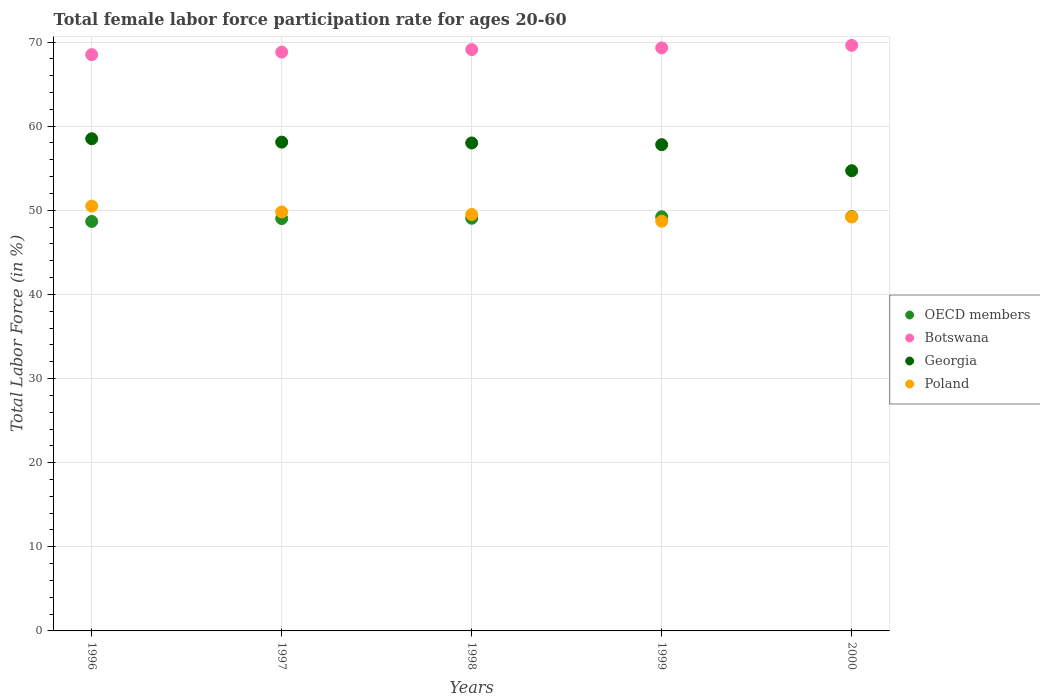How many different coloured dotlines are there?
Offer a very short reply. 4. Is the number of dotlines equal to the number of legend labels?
Your answer should be very brief. Yes. What is the female labor force participation rate in Georgia in 1999?
Ensure brevity in your answer.  57.8. Across all years, what is the maximum female labor force participation rate in Botswana?
Offer a very short reply. 69.6. Across all years, what is the minimum female labor force participation rate in Botswana?
Offer a very short reply. 68.5. In which year was the female labor force participation rate in Botswana maximum?
Provide a succinct answer. 2000. What is the total female labor force participation rate in Georgia in the graph?
Provide a succinct answer. 287.1. What is the difference between the female labor force participation rate in OECD members in 1997 and that in 1998?
Offer a terse response. -0.04. What is the difference between the female labor force participation rate in OECD members in 1999 and the female labor force participation rate in Georgia in 2000?
Your response must be concise. -5.47. What is the average female labor force participation rate in Botswana per year?
Give a very brief answer. 69.06. In the year 2000, what is the difference between the female labor force participation rate in Poland and female labor force participation rate in Botswana?
Your response must be concise. -20.4. In how many years, is the female labor force participation rate in Georgia greater than 64 %?
Offer a terse response. 0. What is the ratio of the female labor force participation rate in Botswana in 1996 to that in 1998?
Keep it short and to the point. 0.99. Is the difference between the female labor force participation rate in Poland in 1997 and 2000 greater than the difference between the female labor force participation rate in Botswana in 1997 and 2000?
Your answer should be compact. Yes. What is the difference between the highest and the second highest female labor force participation rate in Georgia?
Give a very brief answer. 0.4. What is the difference between the highest and the lowest female labor force participation rate in Botswana?
Keep it short and to the point. 1.1. In how many years, is the female labor force participation rate in Poland greater than the average female labor force participation rate in Poland taken over all years?
Your answer should be compact. 2. Is the sum of the female labor force participation rate in Botswana in 1997 and 1998 greater than the maximum female labor force participation rate in Poland across all years?
Ensure brevity in your answer.  Yes. Is it the case that in every year, the sum of the female labor force participation rate in Poland and female labor force participation rate in Georgia  is greater than the sum of female labor force participation rate in Botswana and female labor force participation rate in OECD members?
Keep it short and to the point. No. Is it the case that in every year, the sum of the female labor force participation rate in Poland and female labor force participation rate in Georgia  is greater than the female labor force participation rate in Botswana?
Ensure brevity in your answer.  Yes. How many years are there in the graph?
Your answer should be very brief. 5. Does the graph contain grids?
Your response must be concise. Yes. Where does the legend appear in the graph?
Offer a very short reply. Center right. What is the title of the graph?
Ensure brevity in your answer.  Total female labor force participation rate for ages 20-60. Does "Uganda" appear as one of the legend labels in the graph?
Provide a succinct answer. No. What is the label or title of the Y-axis?
Your answer should be compact. Total Labor Force (in %). What is the Total Labor Force (in %) of OECD members in 1996?
Provide a short and direct response. 48.67. What is the Total Labor Force (in %) of Botswana in 1996?
Your response must be concise. 68.5. What is the Total Labor Force (in %) in Georgia in 1996?
Give a very brief answer. 58.5. What is the Total Labor Force (in %) in Poland in 1996?
Give a very brief answer. 50.5. What is the Total Labor Force (in %) of OECD members in 1997?
Make the answer very short. 49.01. What is the Total Labor Force (in %) of Botswana in 1997?
Offer a very short reply. 68.8. What is the Total Labor Force (in %) in Georgia in 1997?
Your answer should be very brief. 58.1. What is the Total Labor Force (in %) of Poland in 1997?
Offer a terse response. 49.8. What is the Total Labor Force (in %) of OECD members in 1998?
Offer a terse response. 49.05. What is the Total Labor Force (in %) of Botswana in 1998?
Make the answer very short. 69.1. What is the Total Labor Force (in %) of Poland in 1998?
Offer a very short reply. 49.5. What is the Total Labor Force (in %) of OECD members in 1999?
Make the answer very short. 49.23. What is the Total Labor Force (in %) of Botswana in 1999?
Your answer should be compact. 69.3. What is the Total Labor Force (in %) in Georgia in 1999?
Provide a succinct answer. 57.8. What is the Total Labor Force (in %) in Poland in 1999?
Ensure brevity in your answer.  48.7. What is the Total Labor Force (in %) of OECD members in 2000?
Offer a very short reply. 49.25. What is the Total Labor Force (in %) in Botswana in 2000?
Provide a succinct answer. 69.6. What is the Total Labor Force (in %) of Georgia in 2000?
Provide a short and direct response. 54.7. What is the Total Labor Force (in %) in Poland in 2000?
Your response must be concise. 49.2. Across all years, what is the maximum Total Labor Force (in %) of OECD members?
Provide a succinct answer. 49.25. Across all years, what is the maximum Total Labor Force (in %) in Botswana?
Offer a terse response. 69.6. Across all years, what is the maximum Total Labor Force (in %) of Georgia?
Make the answer very short. 58.5. Across all years, what is the maximum Total Labor Force (in %) of Poland?
Ensure brevity in your answer.  50.5. Across all years, what is the minimum Total Labor Force (in %) in OECD members?
Give a very brief answer. 48.67. Across all years, what is the minimum Total Labor Force (in %) of Botswana?
Give a very brief answer. 68.5. Across all years, what is the minimum Total Labor Force (in %) of Georgia?
Make the answer very short. 54.7. Across all years, what is the minimum Total Labor Force (in %) of Poland?
Keep it short and to the point. 48.7. What is the total Total Labor Force (in %) in OECD members in the graph?
Provide a short and direct response. 245.21. What is the total Total Labor Force (in %) of Botswana in the graph?
Your answer should be very brief. 345.3. What is the total Total Labor Force (in %) in Georgia in the graph?
Your answer should be very brief. 287.1. What is the total Total Labor Force (in %) in Poland in the graph?
Keep it short and to the point. 247.7. What is the difference between the Total Labor Force (in %) of OECD members in 1996 and that in 1997?
Keep it short and to the point. -0.34. What is the difference between the Total Labor Force (in %) in Botswana in 1996 and that in 1997?
Ensure brevity in your answer.  -0.3. What is the difference between the Total Labor Force (in %) of OECD members in 1996 and that in 1998?
Keep it short and to the point. -0.38. What is the difference between the Total Labor Force (in %) of OECD members in 1996 and that in 1999?
Provide a short and direct response. -0.55. What is the difference between the Total Labor Force (in %) in Botswana in 1996 and that in 1999?
Provide a succinct answer. -0.8. What is the difference between the Total Labor Force (in %) in Georgia in 1996 and that in 1999?
Offer a terse response. 0.7. What is the difference between the Total Labor Force (in %) in Poland in 1996 and that in 1999?
Keep it short and to the point. 1.8. What is the difference between the Total Labor Force (in %) of OECD members in 1996 and that in 2000?
Your response must be concise. -0.58. What is the difference between the Total Labor Force (in %) in OECD members in 1997 and that in 1998?
Your answer should be compact. -0.04. What is the difference between the Total Labor Force (in %) of Georgia in 1997 and that in 1998?
Provide a succinct answer. 0.1. What is the difference between the Total Labor Force (in %) in OECD members in 1997 and that in 1999?
Ensure brevity in your answer.  -0.21. What is the difference between the Total Labor Force (in %) of Georgia in 1997 and that in 1999?
Give a very brief answer. 0.3. What is the difference between the Total Labor Force (in %) of Poland in 1997 and that in 1999?
Give a very brief answer. 1.1. What is the difference between the Total Labor Force (in %) in OECD members in 1997 and that in 2000?
Your answer should be very brief. -0.24. What is the difference between the Total Labor Force (in %) in Poland in 1997 and that in 2000?
Make the answer very short. 0.6. What is the difference between the Total Labor Force (in %) of OECD members in 1998 and that in 1999?
Offer a very short reply. -0.17. What is the difference between the Total Labor Force (in %) in Georgia in 1998 and that in 1999?
Provide a succinct answer. 0.2. What is the difference between the Total Labor Force (in %) of OECD members in 1998 and that in 2000?
Provide a short and direct response. -0.2. What is the difference between the Total Labor Force (in %) of Botswana in 1998 and that in 2000?
Offer a terse response. -0.5. What is the difference between the Total Labor Force (in %) in Georgia in 1998 and that in 2000?
Make the answer very short. 3.3. What is the difference between the Total Labor Force (in %) of OECD members in 1999 and that in 2000?
Keep it short and to the point. -0.02. What is the difference between the Total Labor Force (in %) of Georgia in 1999 and that in 2000?
Offer a very short reply. 3.1. What is the difference between the Total Labor Force (in %) in Poland in 1999 and that in 2000?
Your answer should be compact. -0.5. What is the difference between the Total Labor Force (in %) of OECD members in 1996 and the Total Labor Force (in %) of Botswana in 1997?
Provide a succinct answer. -20.13. What is the difference between the Total Labor Force (in %) in OECD members in 1996 and the Total Labor Force (in %) in Georgia in 1997?
Offer a very short reply. -9.43. What is the difference between the Total Labor Force (in %) of OECD members in 1996 and the Total Labor Force (in %) of Poland in 1997?
Provide a short and direct response. -1.13. What is the difference between the Total Labor Force (in %) in Botswana in 1996 and the Total Labor Force (in %) in Georgia in 1997?
Offer a terse response. 10.4. What is the difference between the Total Labor Force (in %) of Botswana in 1996 and the Total Labor Force (in %) of Poland in 1997?
Provide a succinct answer. 18.7. What is the difference between the Total Labor Force (in %) in OECD members in 1996 and the Total Labor Force (in %) in Botswana in 1998?
Offer a very short reply. -20.43. What is the difference between the Total Labor Force (in %) of OECD members in 1996 and the Total Labor Force (in %) of Georgia in 1998?
Ensure brevity in your answer.  -9.33. What is the difference between the Total Labor Force (in %) in OECD members in 1996 and the Total Labor Force (in %) in Poland in 1998?
Your answer should be compact. -0.83. What is the difference between the Total Labor Force (in %) in Botswana in 1996 and the Total Labor Force (in %) in Poland in 1998?
Offer a terse response. 19. What is the difference between the Total Labor Force (in %) of Georgia in 1996 and the Total Labor Force (in %) of Poland in 1998?
Offer a very short reply. 9. What is the difference between the Total Labor Force (in %) of OECD members in 1996 and the Total Labor Force (in %) of Botswana in 1999?
Ensure brevity in your answer.  -20.63. What is the difference between the Total Labor Force (in %) of OECD members in 1996 and the Total Labor Force (in %) of Georgia in 1999?
Make the answer very short. -9.13. What is the difference between the Total Labor Force (in %) in OECD members in 1996 and the Total Labor Force (in %) in Poland in 1999?
Your answer should be compact. -0.03. What is the difference between the Total Labor Force (in %) of Botswana in 1996 and the Total Labor Force (in %) of Georgia in 1999?
Your answer should be very brief. 10.7. What is the difference between the Total Labor Force (in %) in Botswana in 1996 and the Total Labor Force (in %) in Poland in 1999?
Ensure brevity in your answer.  19.8. What is the difference between the Total Labor Force (in %) in OECD members in 1996 and the Total Labor Force (in %) in Botswana in 2000?
Offer a terse response. -20.93. What is the difference between the Total Labor Force (in %) of OECD members in 1996 and the Total Labor Force (in %) of Georgia in 2000?
Your response must be concise. -6.03. What is the difference between the Total Labor Force (in %) of OECD members in 1996 and the Total Labor Force (in %) of Poland in 2000?
Make the answer very short. -0.53. What is the difference between the Total Labor Force (in %) of Botswana in 1996 and the Total Labor Force (in %) of Georgia in 2000?
Ensure brevity in your answer.  13.8. What is the difference between the Total Labor Force (in %) in Botswana in 1996 and the Total Labor Force (in %) in Poland in 2000?
Provide a succinct answer. 19.3. What is the difference between the Total Labor Force (in %) in OECD members in 1997 and the Total Labor Force (in %) in Botswana in 1998?
Give a very brief answer. -20.09. What is the difference between the Total Labor Force (in %) of OECD members in 1997 and the Total Labor Force (in %) of Georgia in 1998?
Give a very brief answer. -8.99. What is the difference between the Total Labor Force (in %) of OECD members in 1997 and the Total Labor Force (in %) of Poland in 1998?
Ensure brevity in your answer.  -0.49. What is the difference between the Total Labor Force (in %) of Botswana in 1997 and the Total Labor Force (in %) of Poland in 1998?
Ensure brevity in your answer.  19.3. What is the difference between the Total Labor Force (in %) in Georgia in 1997 and the Total Labor Force (in %) in Poland in 1998?
Offer a terse response. 8.6. What is the difference between the Total Labor Force (in %) of OECD members in 1997 and the Total Labor Force (in %) of Botswana in 1999?
Your answer should be compact. -20.29. What is the difference between the Total Labor Force (in %) in OECD members in 1997 and the Total Labor Force (in %) in Georgia in 1999?
Keep it short and to the point. -8.79. What is the difference between the Total Labor Force (in %) of OECD members in 1997 and the Total Labor Force (in %) of Poland in 1999?
Offer a terse response. 0.31. What is the difference between the Total Labor Force (in %) in Botswana in 1997 and the Total Labor Force (in %) in Poland in 1999?
Offer a very short reply. 20.1. What is the difference between the Total Labor Force (in %) of OECD members in 1997 and the Total Labor Force (in %) of Botswana in 2000?
Ensure brevity in your answer.  -20.59. What is the difference between the Total Labor Force (in %) in OECD members in 1997 and the Total Labor Force (in %) in Georgia in 2000?
Offer a terse response. -5.69. What is the difference between the Total Labor Force (in %) of OECD members in 1997 and the Total Labor Force (in %) of Poland in 2000?
Your response must be concise. -0.19. What is the difference between the Total Labor Force (in %) of Botswana in 1997 and the Total Labor Force (in %) of Georgia in 2000?
Offer a very short reply. 14.1. What is the difference between the Total Labor Force (in %) in Botswana in 1997 and the Total Labor Force (in %) in Poland in 2000?
Offer a terse response. 19.6. What is the difference between the Total Labor Force (in %) in Georgia in 1997 and the Total Labor Force (in %) in Poland in 2000?
Provide a short and direct response. 8.9. What is the difference between the Total Labor Force (in %) in OECD members in 1998 and the Total Labor Force (in %) in Botswana in 1999?
Provide a succinct answer. -20.25. What is the difference between the Total Labor Force (in %) of OECD members in 1998 and the Total Labor Force (in %) of Georgia in 1999?
Your answer should be compact. -8.75. What is the difference between the Total Labor Force (in %) of OECD members in 1998 and the Total Labor Force (in %) of Poland in 1999?
Offer a terse response. 0.35. What is the difference between the Total Labor Force (in %) in Botswana in 1998 and the Total Labor Force (in %) in Georgia in 1999?
Your answer should be compact. 11.3. What is the difference between the Total Labor Force (in %) in Botswana in 1998 and the Total Labor Force (in %) in Poland in 1999?
Provide a succinct answer. 20.4. What is the difference between the Total Labor Force (in %) in OECD members in 1998 and the Total Labor Force (in %) in Botswana in 2000?
Your answer should be very brief. -20.55. What is the difference between the Total Labor Force (in %) in OECD members in 1998 and the Total Labor Force (in %) in Georgia in 2000?
Your answer should be compact. -5.65. What is the difference between the Total Labor Force (in %) of OECD members in 1998 and the Total Labor Force (in %) of Poland in 2000?
Make the answer very short. -0.15. What is the difference between the Total Labor Force (in %) of Botswana in 1998 and the Total Labor Force (in %) of Georgia in 2000?
Offer a terse response. 14.4. What is the difference between the Total Labor Force (in %) of Georgia in 1998 and the Total Labor Force (in %) of Poland in 2000?
Offer a terse response. 8.8. What is the difference between the Total Labor Force (in %) of OECD members in 1999 and the Total Labor Force (in %) of Botswana in 2000?
Your answer should be compact. -20.37. What is the difference between the Total Labor Force (in %) in OECD members in 1999 and the Total Labor Force (in %) in Georgia in 2000?
Provide a short and direct response. -5.47. What is the difference between the Total Labor Force (in %) of OECD members in 1999 and the Total Labor Force (in %) of Poland in 2000?
Provide a succinct answer. 0.03. What is the difference between the Total Labor Force (in %) in Botswana in 1999 and the Total Labor Force (in %) in Georgia in 2000?
Make the answer very short. 14.6. What is the difference between the Total Labor Force (in %) of Botswana in 1999 and the Total Labor Force (in %) of Poland in 2000?
Your answer should be compact. 20.1. What is the difference between the Total Labor Force (in %) in Georgia in 1999 and the Total Labor Force (in %) in Poland in 2000?
Your answer should be compact. 8.6. What is the average Total Labor Force (in %) in OECD members per year?
Your response must be concise. 49.04. What is the average Total Labor Force (in %) of Botswana per year?
Provide a short and direct response. 69.06. What is the average Total Labor Force (in %) in Georgia per year?
Your answer should be very brief. 57.42. What is the average Total Labor Force (in %) of Poland per year?
Your answer should be very brief. 49.54. In the year 1996, what is the difference between the Total Labor Force (in %) in OECD members and Total Labor Force (in %) in Botswana?
Your answer should be very brief. -19.83. In the year 1996, what is the difference between the Total Labor Force (in %) in OECD members and Total Labor Force (in %) in Georgia?
Offer a very short reply. -9.83. In the year 1996, what is the difference between the Total Labor Force (in %) of OECD members and Total Labor Force (in %) of Poland?
Offer a very short reply. -1.83. In the year 1996, what is the difference between the Total Labor Force (in %) in Botswana and Total Labor Force (in %) in Georgia?
Provide a succinct answer. 10. In the year 1996, what is the difference between the Total Labor Force (in %) of Georgia and Total Labor Force (in %) of Poland?
Your response must be concise. 8. In the year 1997, what is the difference between the Total Labor Force (in %) of OECD members and Total Labor Force (in %) of Botswana?
Give a very brief answer. -19.79. In the year 1997, what is the difference between the Total Labor Force (in %) of OECD members and Total Labor Force (in %) of Georgia?
Make the answer very short. -9.09. In the year 1997, what is the difference between the Total Labor Force (in %) of OECD members and Total Labor Force (in %) of Poland?
Your response must be concise. -0.79. In the year 1997, what is the difference between the Total Labor Force (in %) in Botswana and Total Labor Force (in %) in Poland?
Offer a very short reply. 19. In the year 1998, what is the difference between the Total Labor Force (in %) of OECD members and Total Labor Force (in %) of Botswana?
Offer a terse response. -20.05. In the year 1998, what is the difference between the Total Labor Force (in %) in OECD members and Total Labor Force (in %) in Georgia?
Your answer should be very brief. -8.95. In the year 1998, what is the difference between the Total Labor Force (in %) in OECD members and Total Labor Force (in %) in Poland?
Offer a terse response. -0.45. In the year 1998, what is the difference between the Total Labor Force (in %) of Botswana and Total Labor Force (in %) of Poland?
Provide a short and direct response. 19.6. In the year 1998, what is the difference between the Total Labor Force (in %) in Georgia and Total Labor Force (in %) in Poland?
Give a very brief answer. 8.5. In the year 1999, what is the difference between the Total Labor Force (in %) in OECD members and Total Labor Force (in %) in Botswana?
Offer a very short reply. -20.07. In the year 1999, what is the difference between the Total Labor Force (in %) in OECD members and Total Labor Force (in %) in Georgia?
Offer a terse response. -8.57. In the year 1999, what is the difference between the Total Labor Force (in %) of OECD members and Total Labor Force (in %) of Poland?
Provide a succinct answer. 0.53. In the year 1999, what is the difference between the Total Labor Force (in %) in Botswana and Total Labor Force (in %) in Georgia?
Your response must be concise. 11.5. In the year 1999, what is the difference between the Total Labor Force (in %) of Botswana and Total Labor Force (in %) of Poland?
Offer a terse response. 20.6. In the year 1999, what is the difference between the Total Labor Force (in %) of Georgia and Total Labor Force (in %) of Poland?
Ensure brevity in your answer.  9.1. In the year 2000, what is the difference between the Total Labor Force (in %) in OECD members and Total Labor Force (in %) in Botswana?
Provide a short and direct response. -20.35. In the year 2000, what is the difference between the Total Labor Force (in %) in OECD members and Total Labor Force (in %) in Georgia?
Offer a terse response. -5.45. In the year 2000, what is the difference between the Total Labor Force (in %) in OECD members and Total Labor Force (in %) in Poland?
Your answer should be very brief. 0.05. In the year 2000, what is the difference between the Total Labor Force (in %) in Botswana and Total Labor Force (in %) in Georgia?
Provide a short and direct response. 14.9. In the year 2000, what is the difference between the Total Labor Force (in %) of Botswana and Total Labor Force (in %) of Poland?
Provide a short and direct response. 20.4. What is the ratio of the Total Labor Force (in %) of OECD members in 1996 to that in 1997?
Your response must be concise. 0.99. What is the ratio of the Total Labor Force (in %) of Poland in 1996 to that in 1997?
Provide a succinct answer. 1.01. What is the ratio of the Total Labor Force (in %) in Botswana in 1996 to that in 1998?
Your answer should be very brief. 0.99. What is the ratio of the Total Labor Force (in %) of Georgia in 1996 to that in 1998?
Your response must be concise. 1.01. What is the ratio of the Total Labor Force (in %) in Poland in 1996 to that in 1998?
Give a very brief answer. 1.02. What is the ratio of the Total Labor Force (in %) in OECD members in 1996 to that in 1999?
Your answer should be compact. 0.99. What is the ratio of the Total Labor Force (in %) of Georgia in 1996 to that in 1999?
Make the answer very short. 1.01. What is the ratio of the Total Labor Force (in %) of Poland in 1996 to that in 1999?
Give a very brief answer. 1.04. What is the ratio of the Total Labor Force (in %) in OECD members in 1996 to that in 2000?
Your response must be concise. 0.99. What is the ratio of the Total Labor Force (in %) in Botswana in 1996 to that in 2000?
Give a very brief answer. 0.98. What is the ratio of the Total Labor Force (in %) in Georgia in 1996 to that in 2000?
Your answer should be compact. 1.07. What is the ratio of the Total Labor Force (in %) of Poland in 1996 to that in 2000?
Provide a succinct answer. 1.03. What is the ratio of the Total Labor Force (in %) of Botswana in 1997 to that in 1998?
Provide a short and direct response. 1. What is the ratio of the Total Labor Force (in %) in Georgia in 1997 to that in 1998?
Provide a short and direct response. 1. What is the ratio of the Total Labor Force (in %) of Poland in 1997 to that in 1998?
Your response must be concise. 1.01. What is the ratio of the Total Labor Force (in %) in Georgia in 1997 to that in 1999?
Your response must be concise. 1.01. What is the ratio of the Total Labor Force (in %) in Poland in 1997 to that in 1999?
Ensure brevity in your answer.  1.02. What is the ratio of the Total Labor Force (in %) in Botswana in 1997 to that in 2000?
Your answer should be very brief. 0.99. What is the ratio of the Total Labor Force (in %) of Georgia in 1997 to that in 2000?
Your answer should be very brief. 1.06. What is the ratio of the Total Labor Force (in %) of Poland in 1997 to that in 2000?
Offer a terse response. 1.01. What is the ratio of the Total Labor Force (in %) in OECD members in 1998 to that in 1999?
Your response must be concise. 1. What is the ratio of the Total Labor Force (in %) in Botswana in 1998 to that in 1999?
Provide a succinct answer. 1. What is the ratio of the Total Labor Force (in %) in Georgia in 1998 to that in 1999?
Your answer should be very brief. 1. What is the ratio of the Total Labor Force (in %) of Poland in 1998 to that in 1999?
Your answer should be very brief. 1.02. What is the ratio of the Total Labor Force (in %) of OECD members in 1998 to that in 2000?
Give a very brief answer. 1. What is the ratio of the Total Labor Force (in %) of Georgia in 1998 to that in 2000?
Make the answer very short. 1.06. What is the ratio of the Total Labor Force (in %) in Georgia in 1999 to that in 2000?
Your answer should be very brief. 1.06. What is the difference between the highest and the second highest Total Labor Force (in %) of OECD members?
Your response must be concise. 0.02. What is the difference between the highest and the lowest Total Labor Force (in %) in OECD members?
Your response must be concise. 0.58. What is the difference between the highest and the lowest Total Labor Force (in %) in Botswana?
Your answer should be compact. 1.1. What is the difference between the highest and the lowest Total Labor Force (in %) of Georgia?
Offer a terse response. 3.8. 